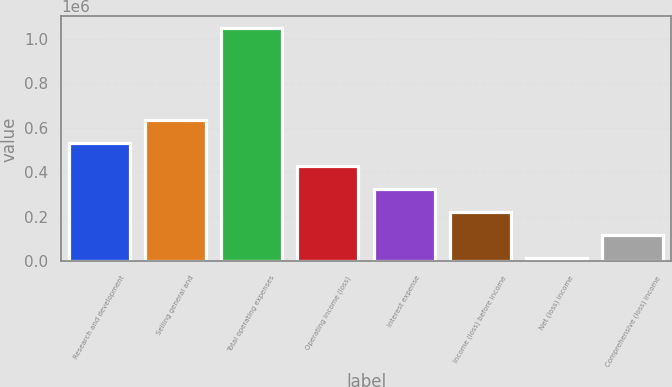Convert chart to OTSL. <chart><loc_0><loc_0><loc_500><loc_500><bar_chart><fcel>Research and development<fcel>Selling general and<fcel>Total operating expenses<fcel>Operating income (loss)<fcel>Interest expense<fcel>Income (loss) before income<fcel>Net (loss) income<fcel>Comprehensive (loss) income<nl><fcel>532006<fcel>635095<fcel>1.04745e+06<fcel>428916<fcel>325826<fcel>222737<fcel>16558<fcel>119648<nl></chart> 